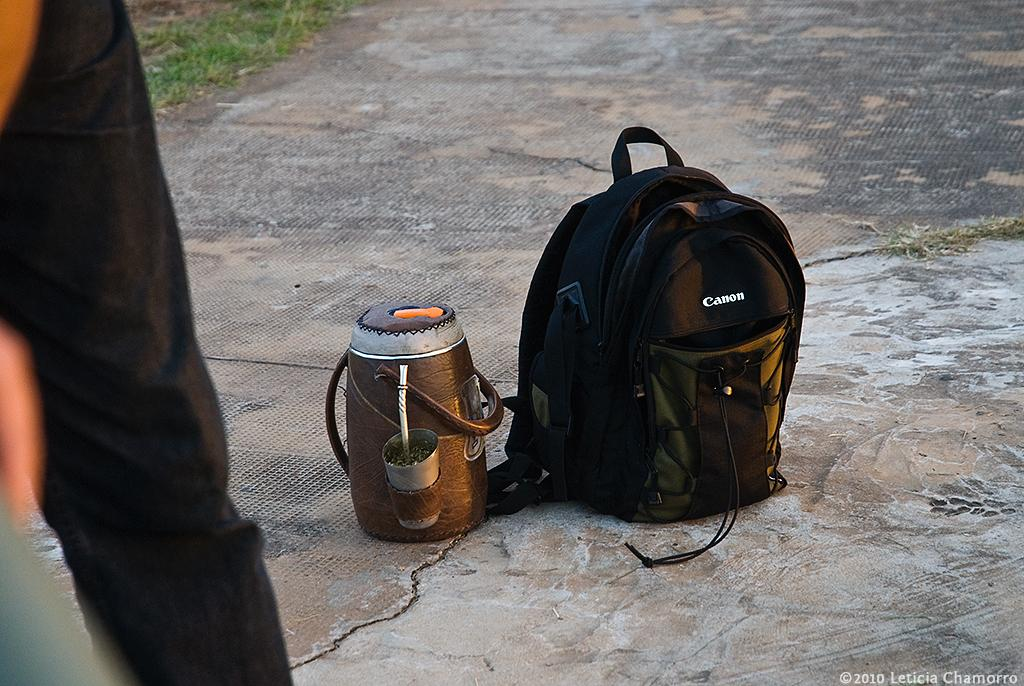<image>
Render a clear and concise summary of the photo. A black Canon backpack or camera bag sitting on a cement road. 